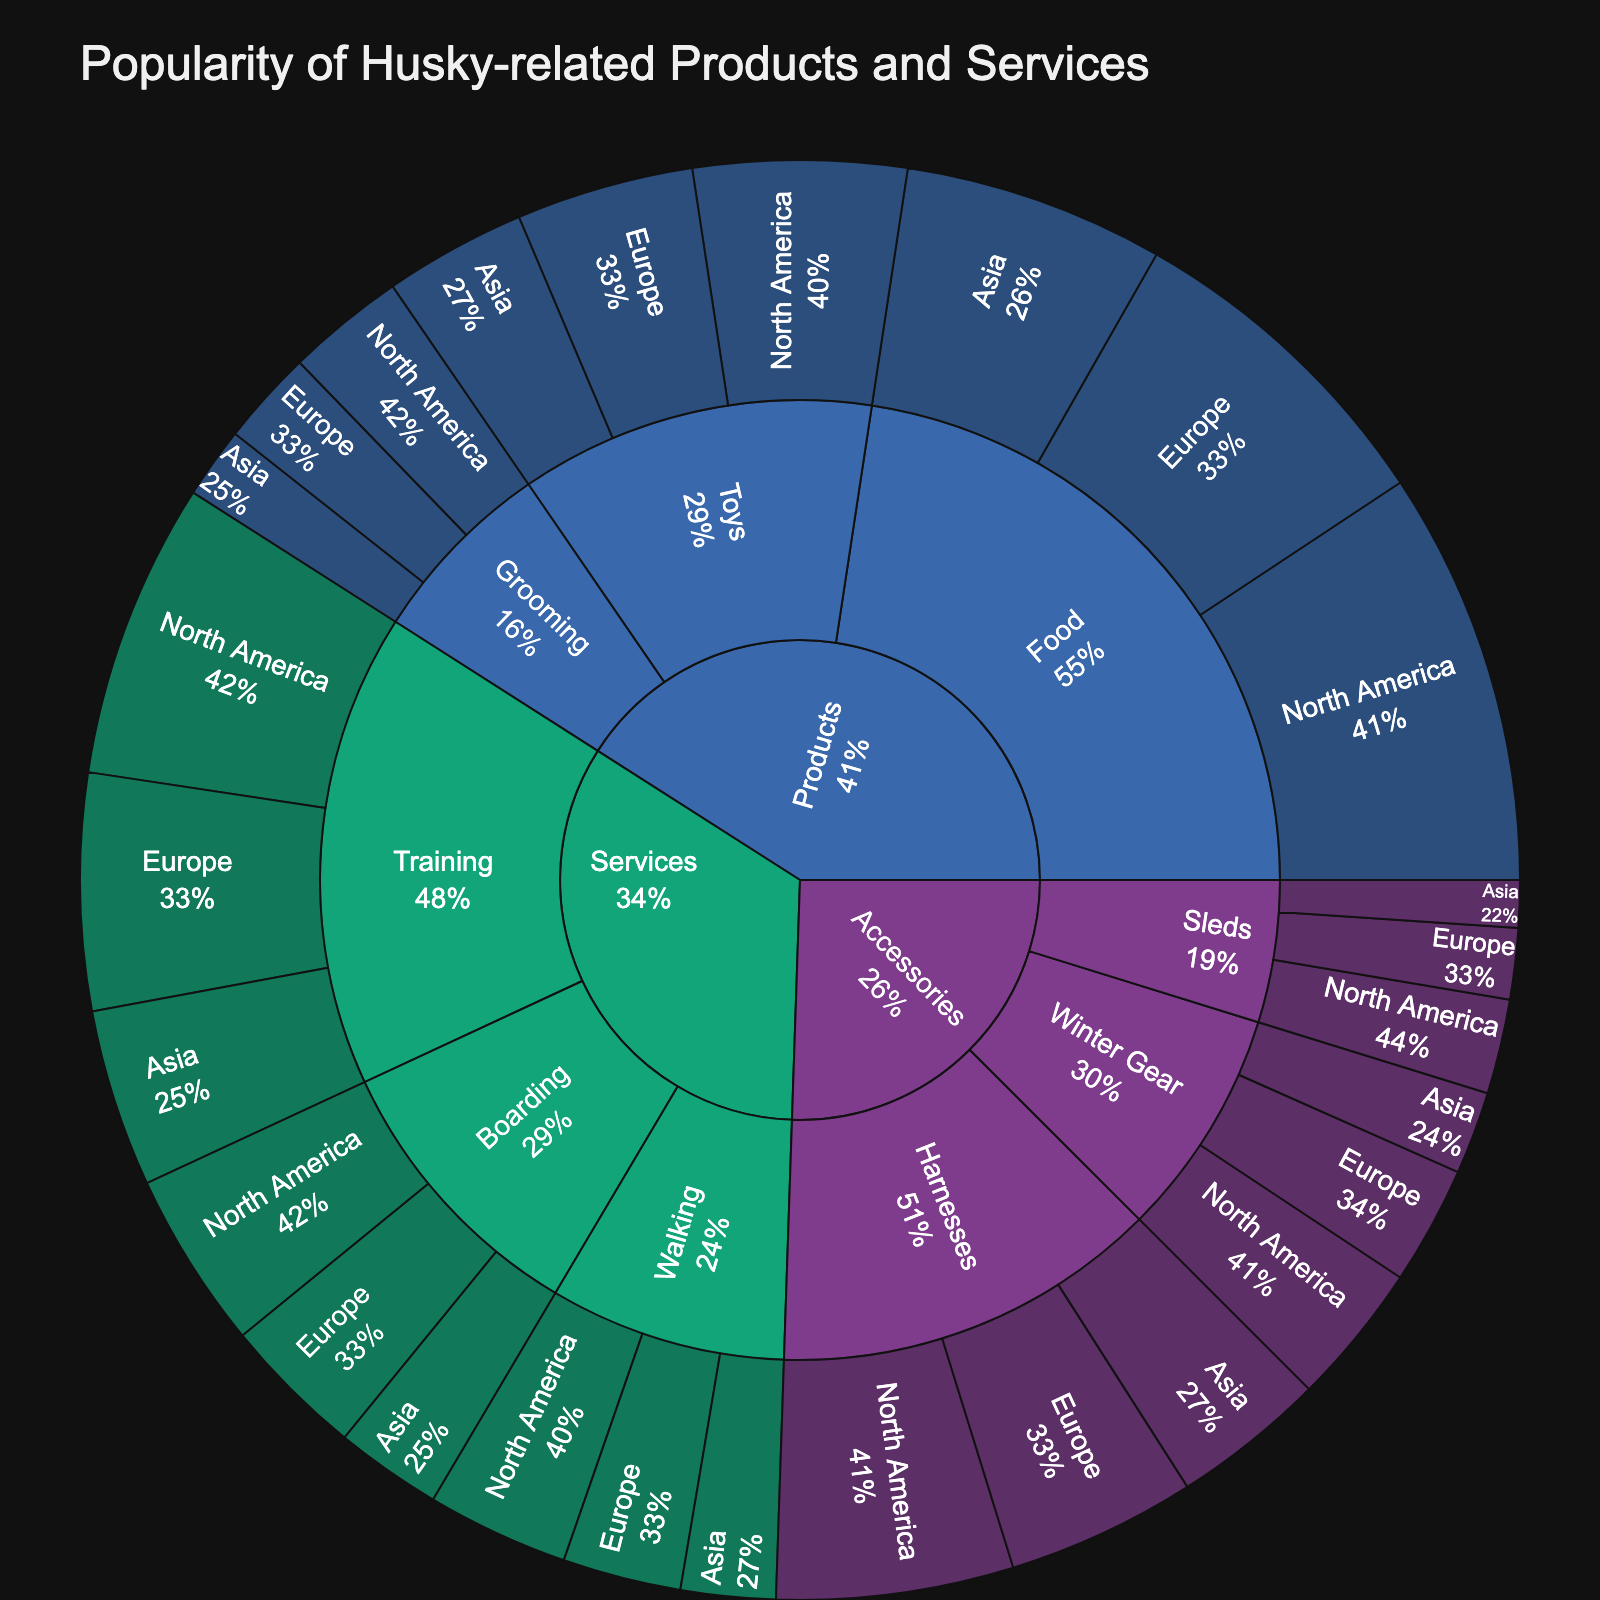what is the overall title of the figure? The title of the figure is located at the top and often summarizes what the figure represents. In this case, it should mention the central theme regarding Husky-related products and services.
Answer: Popularity of Husky-related Products and Services Which category has the highest value in North America? By examining the sector sizes and values, one should look at all the categories within North America and identify the category with the largest value.
Answer: Products - Food What is the combined value of Training services in all regions? To find the total value of Training services, sum the values of Training services across North America, Europe, and Asia regions. 25 (NA) + 20 (EU) + 15 (AS) = 60
Answer: 60 Considering Food subcategory only, which region has the least popularity? For the Food subcategory, we compare the values in North America, Europe, and Asia regions. The least value indicates the least popularity.
Answer: Asia Which category has the smallest representation in the figure? To identify the smallest category, one must locate the category with the smallest aggregated value across all regions. This involves comparing aggregate sizes of each category.
Answer: Accessories - Sleds How does the value of Toys in Europe compare to Grooming in Asia? We check the respective values for both Toys in Europe and Grooming in Asia and make a direct comparison between the two. Toys in Europe: 15, Grooming in Asia: 6. Thus, Toys in Europe is more popular.
Answer: Toys in Europe > Grooming in Asia What percentage of the Products value does Toys in North America represent for that category? First, find the total value of Products in North America (35+18+10 = 63), then calculate the percentage represented by Toys (18/63 * 100%).
Answer: Approximately 28.6% Which region has the highest popularity for Boarding services? By comparing the values of Boarding services across all regions, the one with the highest value indicates the highest popularity.
Answer: North America What is the proportion of Accessories compared to all categories in Asia? Calculate the total value of Accessories in Asia (13+4+7 = 24), and then divide it by the sum of values for all categories in Asia (22+12+6+15+8+9+13+4+7 = 96). (24/96) * 100%
Answer: 25% Between Europe and Asia, which region has a higher value for Winter Gear? By directly comparing the values given for Winter Gear in Europe and Asia, we identify which one is higher. Winter Gear in Europe: 10, in Asia: 7.
Answer: Europe 